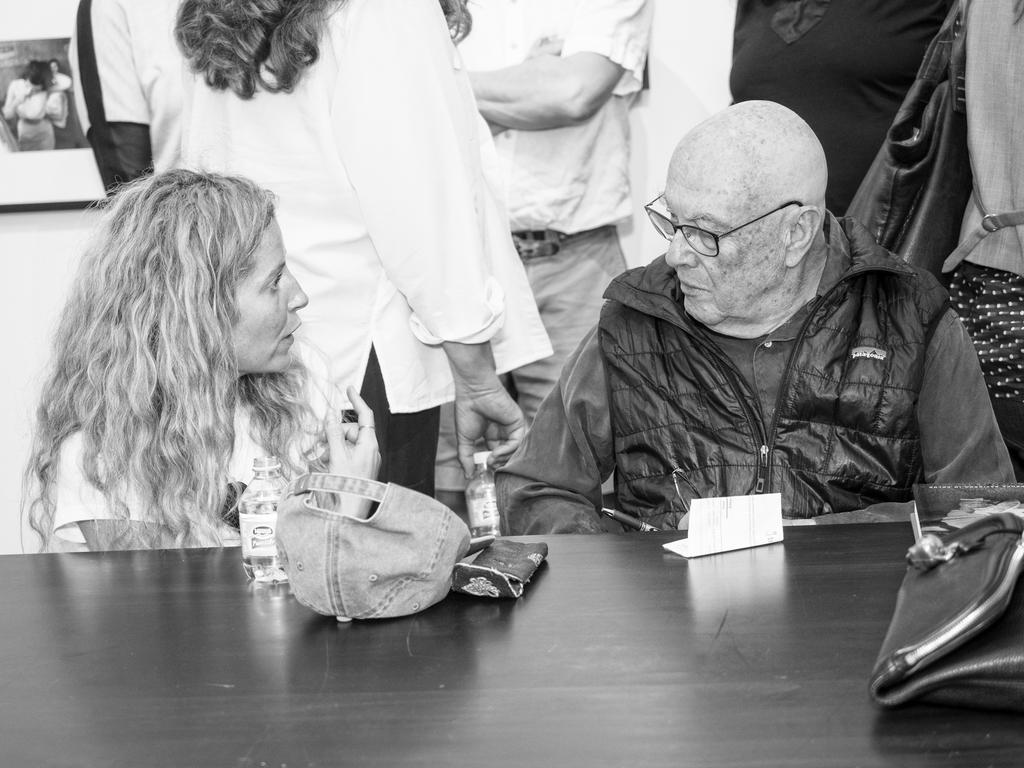How many people are sitting in the image? There are two persons sitting in the image. Are there any people standing in the image? Yes, there are people standing in the image. What is one person wearing that is visible in the image? One person is wearing a bag. What objects can be seen on the table in the image? There is a bottle, a cap, a paper, and a bag on the table. What is visible in the background of the image? There is a wall and a frame on the wall in the background. What type of thread is being used to paint the pollution in the image? There is no thread, paint, or pollution present in the image. 